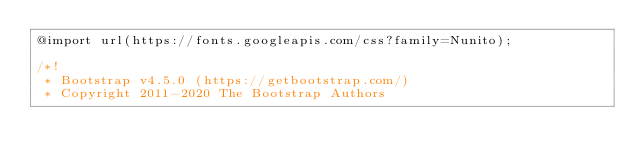<code> <loc_0><loc_0><loc_500><loc_500><_CSS_>@import url(https://fonts.googleapis.com/css?family=Nunito);

/*!
 * Bootstrap v4.5.0 (https://getbootstrap.com/)
 * Copyright 2011-2020 The Bootstrap Authors</code> 